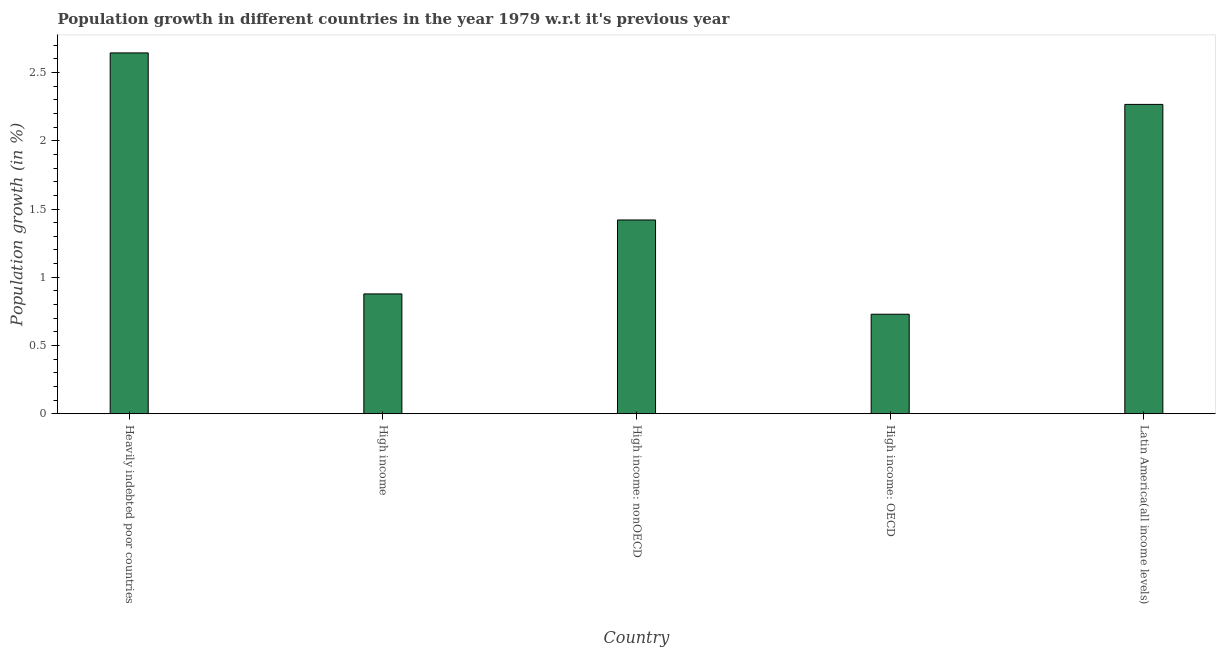Does the graph contain grids?
Ensure brevity in your answer.  No. What is the title of the graph?
Provide a succinct answer. Population growth in different countries in the year 1979 w.r.t it's previous year. What is the label or title of the X-axis?
Your answer should be very brief. Country. What is the label or title of the Y-axis?
Make the answer very short. Population growth (in %). What is the population growth in High income?
Offer a very short reply. 0.88. Across all countries, what is the maximum population growth?
Your answer should be compact. 2.64. Across all countries, what is the minimum population growth?
Make the answer very short. 0.73. In which country was the population growth maximum?
Your response must be concise. Heavily indebted poor countries. In which country was the population growth minimum?
Keep it short and to the point. High income: OECD. What is the sum of the population growth?
Provide a short and direct response. 7.94. What is the difference between the population growth in Heavily indebted poor countries and High income?
Give a very brief answer. 1.77. What is the average population growth per country?
Your response must be concise. 1.59. What is the median population growth?
Your answer should be very brief. 1.42. What is the ratio of the population growth in High income: OECD to that in Latin America(all income levels)?
Offer a very short reply. 0.32. Is the population growth in High income: nonOECD less than that in Latin America(all income levels)?
Give a very brief answer. Yes. What is the difference between the highest and the second highest population growth?
Provide a short and direct response. 0.38. What is the difference between the highest and the lowest population growth?
Give a very brief answer. 1.91. In how many countries, is the population growth greater than the average population growth taken over all countries?
Your answer should be compact. 2. How many bars are there?
Ensure brevity in your answer.  5. Are all the bars in the graph horizontal?
Make the answer very short. No. How many countries are there in the graph?
Ensure brevity in your answer.  5. What is the Population growth (in %) of Heavily indebted poor countries?
Offer a terse response. 2.64. What is the Population growth (in %) of High income?
Your answer should be compact. 0.88. What is the Population growth (in %) in High income: nonOECD?
Provide a short and direct response. 1.42. What is the Population growth (in %) of High income: OECD?
Offer a terse response. 0.73. What is the Population growth (in %) of Latin America(all income levels)?
Your answer should be very brief. 2.27. What is the difference between the Population growth (in %) in Heavily indebted poor countries and High income?
Your answer should be very brief. 1.77. What is the difference between the Population growth (in %) in Heavily indebted poor countries and High income: nonOECD?
Give a very brief answer. 1.22. What is the difference between the Population growth (in %) in Heavily indebted poor countries and High income: OECD?
Your response must be concise. 1.91. What is the difference between the Population growth (in %) in Heavily indebted poor countries and Latin America(all income levels)?
Provide a succinct answer. 0.38. What is the difference between the Population growth (in %) in High income and High income: nonOECD?
Offer a terse response. -0.54. What is the difference between the Population growth (in %) in High income and High income: OECD?
Your answer should be compact. 0.15. What is the difference between the Population growth (in %) in High income and Latin America(all income levels)?
Make the answer very short. -1.39. What is the difference between the Population growth (in %) in High income: nonOECD and High income: OECD?
Give a very brief answer. 0.69. What is the difference between the Population growth (in %) in High income: nonOECD and Latin America(all income levels)?
Make the answer very short. -0.85. What is the difference between the Population growth (in %) in High income: OECD and Latin America(all income levels)?
Give a very brief answer. -1.54. What is the ratio of the Population growth (in %) in Heavily indebted poor countries to that in High income?
Your answer should be very brief. 3.01. What is the ratio of the Population growth (in %) in Heavily indebted poor countries to that in High income: nonOECD?
Keep it short and to the point. 1.86. What is the ratio of the Population growth (in %) in Heavily indebted poor countries to that in High income: OECD?
Give a very brief answer. 3.63. What is the ratio of the Population growth (in %) in Heavily indebted poor countries to that in Latin America(all income levels)?
Make the answer very short. 1.17. What is the ratio of the Population growth (in %) in High income to that in High income: nonOECD?
Provide a succinct answer. 0.62. What is the ratio of the Population growth (in %) in High income to that in High income: OECD?
Your response must be concise. 1.2. What is the ratio of the Population growth (in %) in High income to that in Latin America(all income levels)?
Ensure brevity in your answer.  0.39. What is the ratio of the Population growth (in %) in High income: nonOECD to that in High income: OECD?
Provide a short and direct response. 1.95. What is the ratio of the Population growth (in %) in High income: nonOECD to that in Latin America(all income levels)?
Provide a short and direct response. 0.63. What is the ratio of the Population growth (in %) in High income: OECD to that in Latin America(all income levels)?
Your answer should be compact. 0.32. 